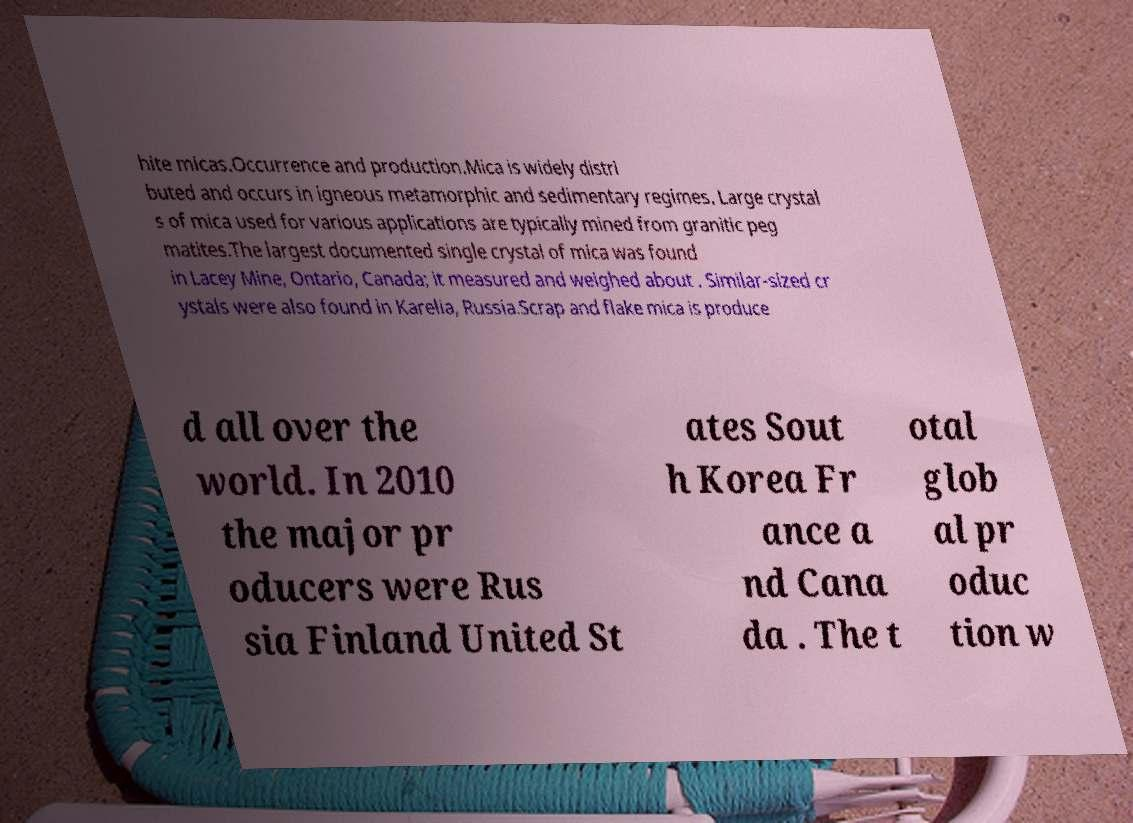Please identify and transcribe the text found in this image. hite micas.Occurrence and production.Mica is widely distri buted and occurs in igneous metamorphic and sedimentary regimes. Large crystal s of mica used for various applications are typically mined from granitic peg matites.The largest documented single crystal of mica was found in Lacey Mine, Ontario, Canada; it measured and weighed about . Similar-sized cr ystals were also found in Karelia, Russia.Scrap and flake mica is produce d all over the world. In 2010 the major pr oducers were Rus sia Finland United St ates Sout h Korea Fr ance a nd Cana da . The t otal glob al pr oduc tion w 